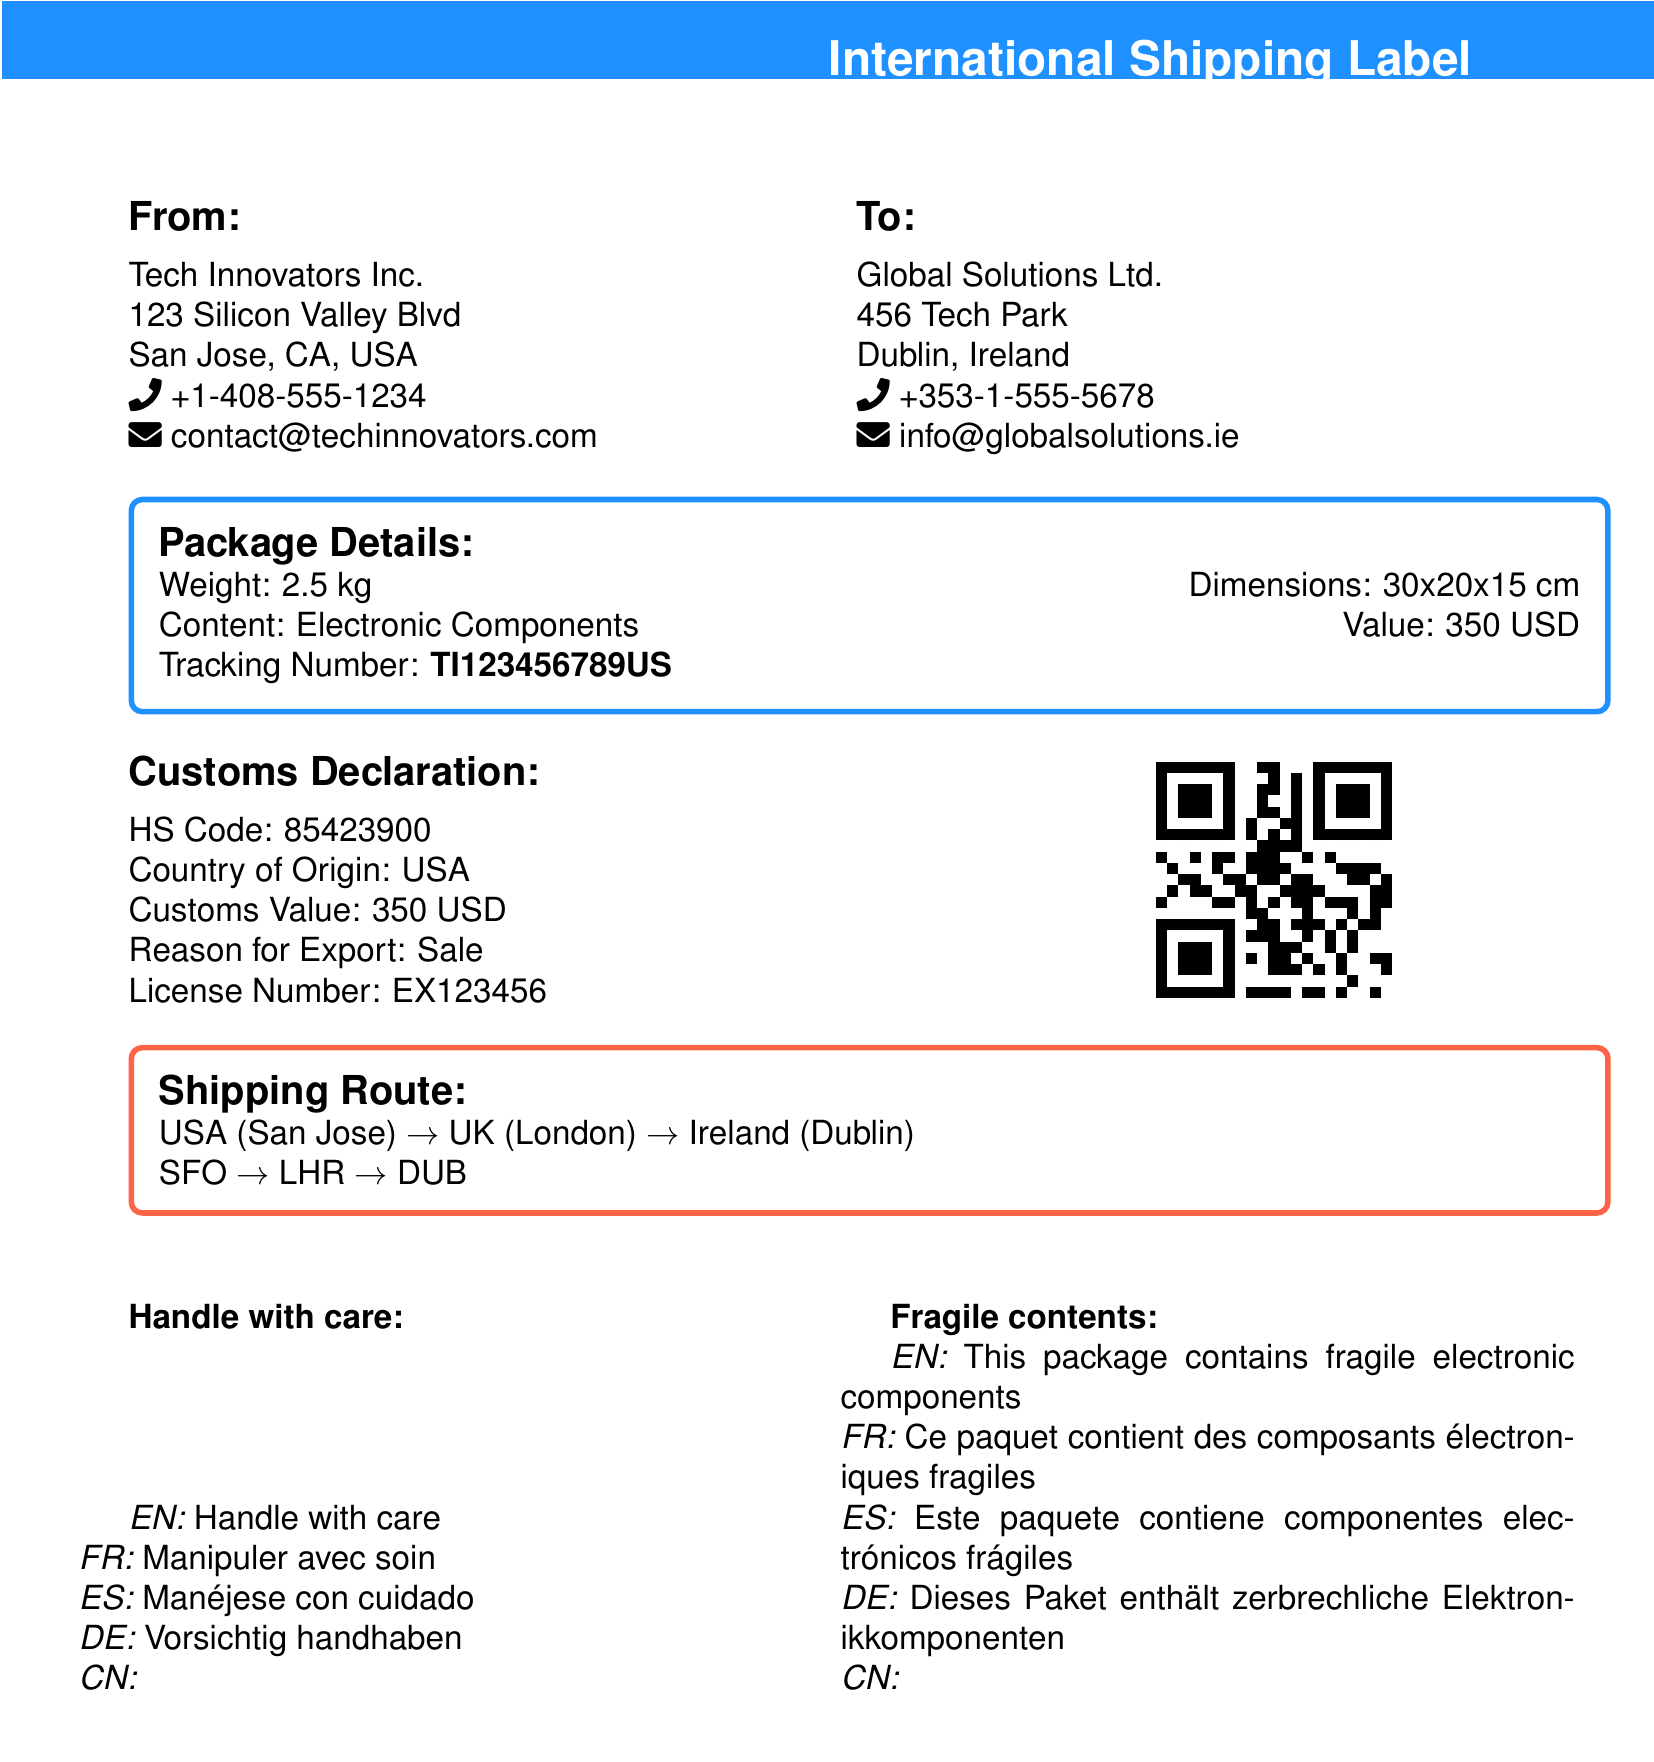What is the weight of the package? The weight of the package is mentioned in the package details section of the document.
Answer: 2.5 kg What is the tracking number? The tracking number can be found in the package details provided.
Answer: TI123456789US What is the country of origin? The country of origin is specified in the customs declaration section.
Answer: USA What is the HS code? The HS code is listed in the customs declaration area of the document.
Answer: 85423900 Which company is the sender? The sender's company name is provided in the 'From' section.
Answer: Tech Innovators Inc What is the reason for export? The reason for export is stated in the customs declaration section.
Answer: Sale What shipping route is indicated? The shipping route details are described clearly in the shipping route section.
Answer: USA (San Jose) → UK (London) → Ireland (Dublin) Which languages are used for handling instructions? The languages used for handling instructions are included in the handling instructions section of the document.
Answer: English, French, Spanish, German, Chinese How many fragile content translations are provided? The number of translations provided for fragile content is counted in the document.
Answer: Five 